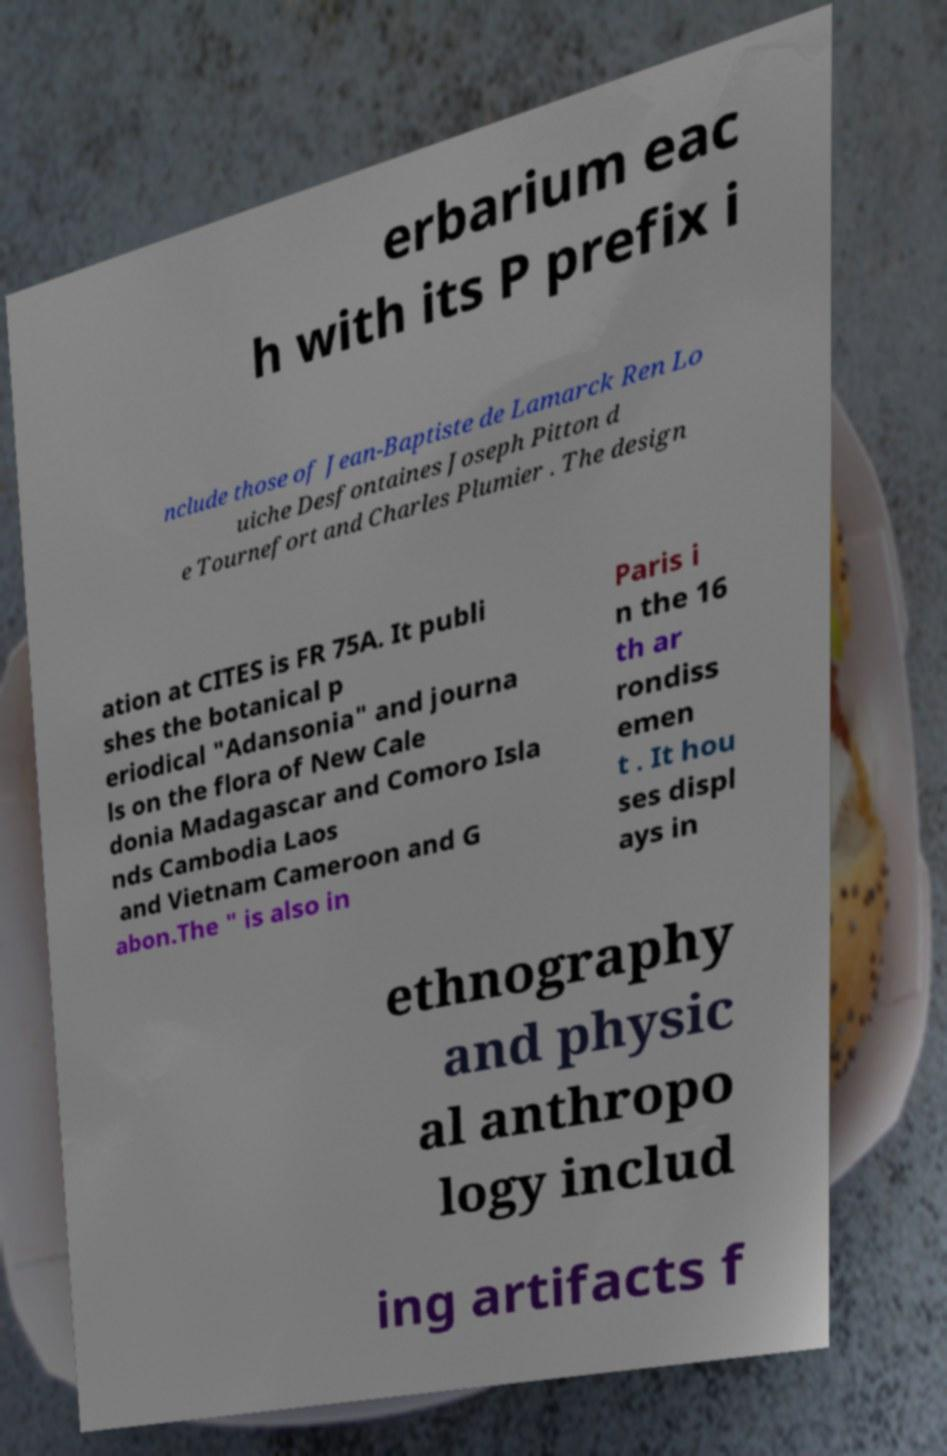Could you extract and type out the text from this image? erbarium eac h with its P prefix i nclude those of Jean-Baptiste de Lamarck Ren Lo uiche Desfontaines Joseph Pitton d e Tournefort and Charles Plumier . The design ation at CITES is FR 75A. It publi shes the botanical p eriodical "Adansonia" and journa ls on the flora of New Cale donia Madagascar and Comoro Isla nds Cambodia Laos and Vietnam Cameroon and G abon.The " is also in Paris i n the 16 th ar rondiss emen t . It hou ses displ ays in ethnography and physic al anthropo logy includ ing artifacts f 